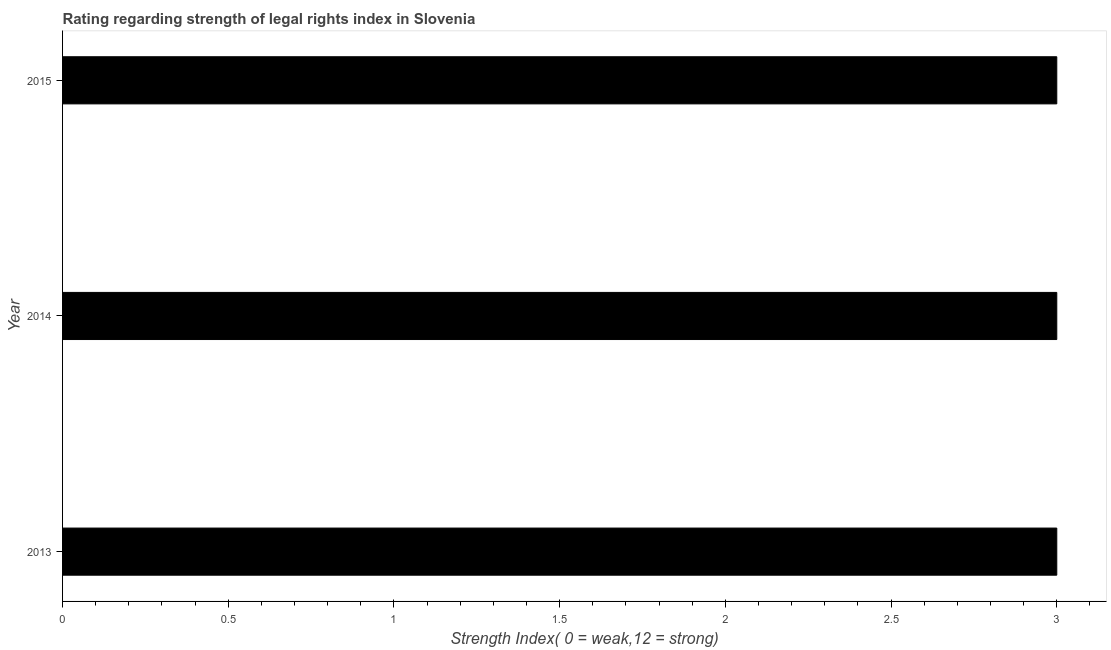Does the graph contain any zero values?
Your response must be concise. No. What is the title of the graph?
Your answer should be very brief. Rating regarding strength of legal rights index in Slovenia. What is the label or title of the X-axis?
Make the answer very short. Strength Index( 0 = weak,12 = strong). What is the label or title of the Y-axis?
Your answer should be very brief. Year. Across all years, what is the maximum strength of legal rights index?
Keep it short and to the point. 3. Across all years, what is the minimum strength of legal rights index?
Offer a very short reply. 3. In which year was the strength of legal rights index maximum?
Your response must be concise. 2013. What is the average strength of legal rights index per year?
Your answer should be very brief. 3. What is the median strength of legal rights index?
Give a very brief answer. 3. What is the ratio of the strength of legal rights index in 2013 to that in 2014?
Ensure brevity in your answer.  1. What is the difference between the highest and the second highest strength of legal rights index?
Your response must be concise. 0. Is the sum of the strength of legal rights index in 2014 and 2015 greater than the maximum strength of legal rights index across all years?
Provide a succinct answer. Yes. What is the difference between the highest and the lowest strength of legal rights index?
Your answer should be compact. 0. In how many years, is the strength of legal rights index greater than the average strength of legal rights index taken over all years?
Offer a very short reply. 0. Are all the bars in the graph horizontal?
Offer a terse response. Yes. How many years are there in the graph?
Offer a terse response. 3. What is the difference between two consecutive major ticks on the X-axis?
Provide a short and direct response. 0.5. What is the Strength Index( 0 = weak,12 = strong) of 2014?
Your answer should be compact. 3. What is the difference between the Strength Index( 0 = weak,12 = strong) in 2014 and 2015?
Provide a succinct answer. 0. What is the ratio of the Strength Index( 0 = weak,12 = strong) in 2014 to that in 2015?
Offer a terse response. 1. 